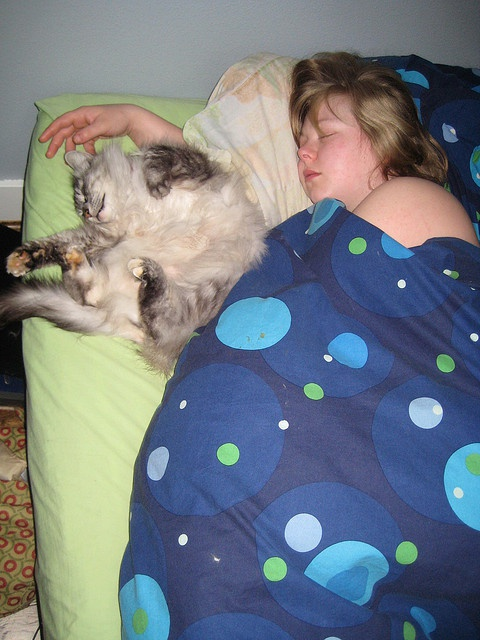Describe the objects in this image and their specific colors. I can see cat in gray, darkgray, and tan tones, bed in gray, khaki, and tan tones, and people in gray, lightpink, black, and tan tones in this image. 